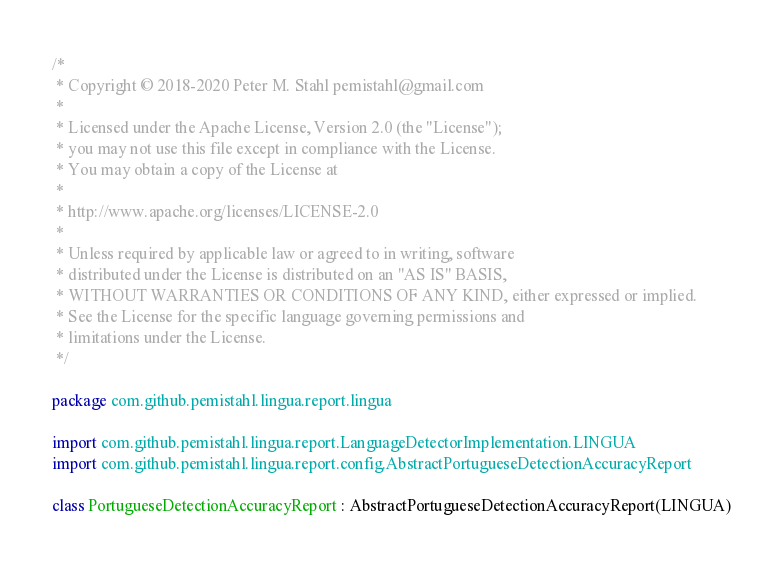<code> <loc_0><loc_0><loc_500><loc_500><_Kotlin_>/*
 * Copyright © 2018-2020 Peter M. Stahl pemistahl@gmail.com
 *
 * Licensed under the Apache License, Version 2.0 (the "License");
 * you may not use this file except in compliance with the License.
 * You may obtain a copy of the License at
 *
 * http://www.apache.org/licenses/LICENSE-2.0
 *
 * Unless required by applicable law or agreed to in writing, software
 * distributed under the License is distributed on an "AS IS" BASIS,
 * WITHOUT WARRANTIES OR CONDITIONS OF ANY KIND, either expressed or implied.
 * See the License for the specific language governing permissions and
 * limitations under the License.
 */

package com.github.pemistahl.lingua.report.lingua

import com.github.pemistahl.lingua.report.LanguageDetectorImplementation.LINGUA
import com.github.pemistahl.lingua.report.config.AbstractPortugueseDetectionAccuracyReport

class PortugueseDetectionAccuracyReport : AbstractPortugueseDetectionAccuracyReport(LINGUA)
</code> 